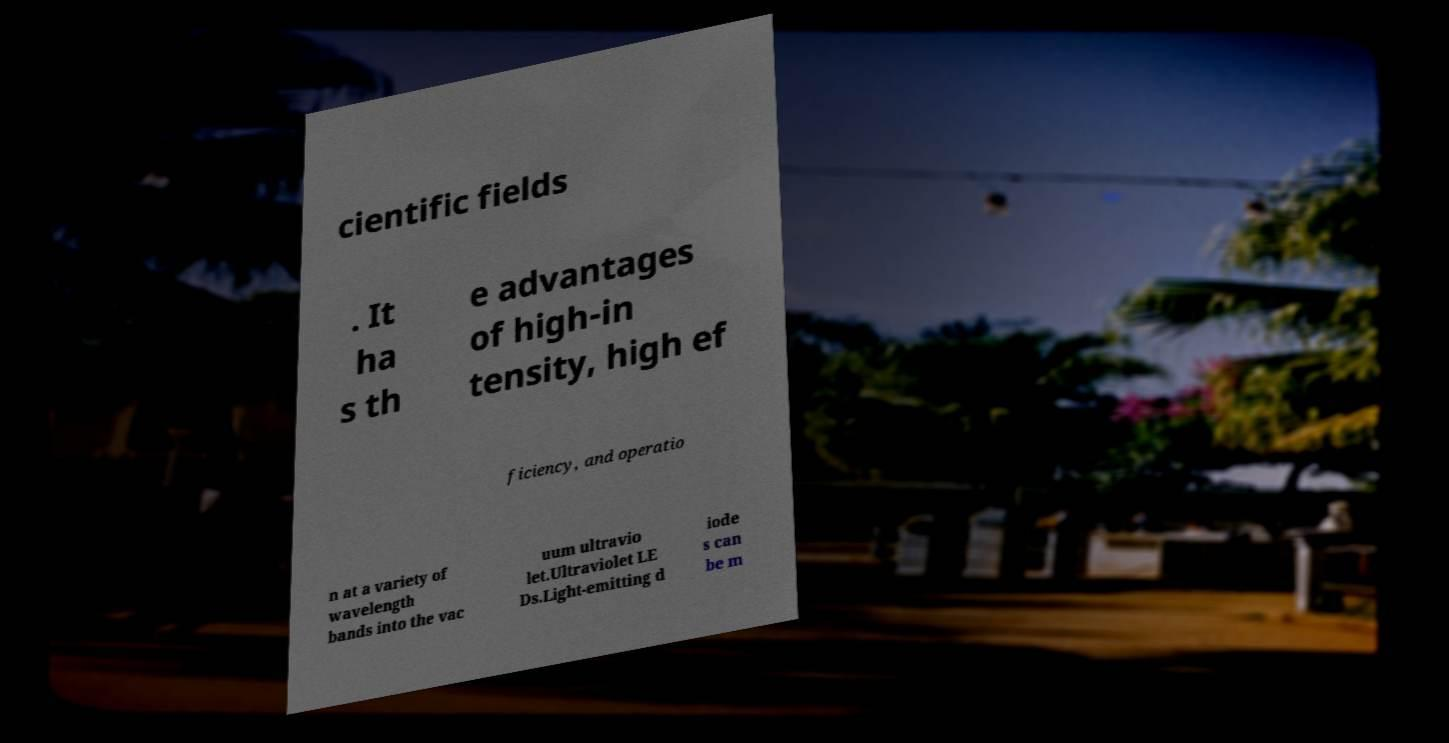Can you accurately transcribe the text from the provided image for me? cientific fields . It ha s th e advantages of high-in tensity, high ef ficiency, and operatio n at a variety of wavelength bands into the vac uum ultravio let.Ultraviolet LE Ds.Light-emitting d iode s can be m 